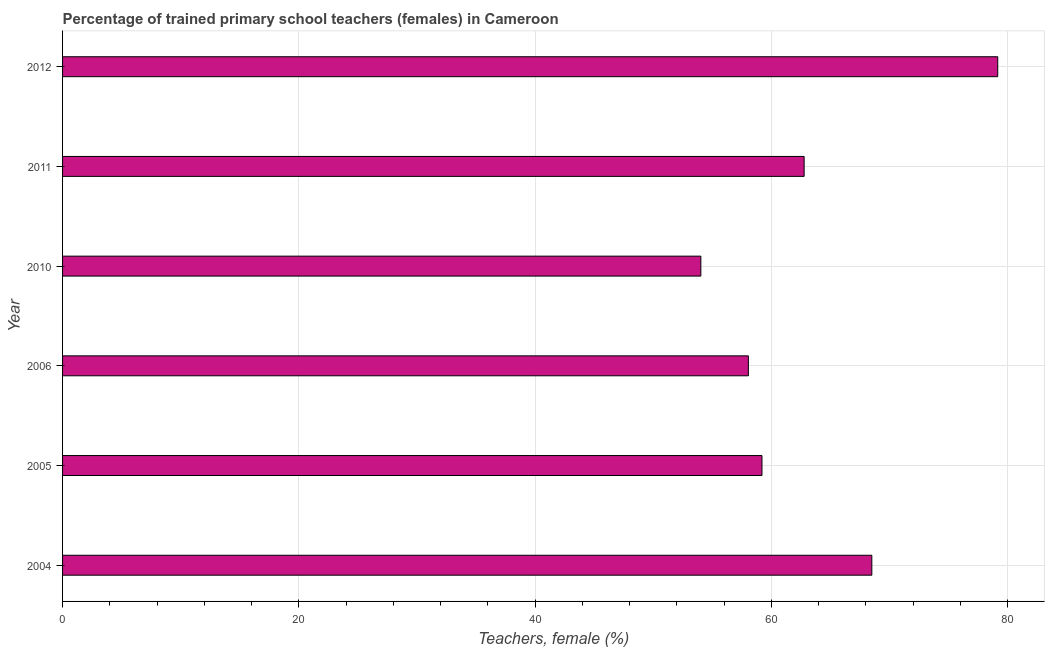Does the graph contain any zero values?
Provide a succinct answer. No. What is the title of the graph?
Make the answer very short. Percentage of trained primary school teachers (females) in Cameroon. What is the label or title of the X-axis?
Your response must be concise. Teachers, female (%). What is the label or title of the Y-axis?
Offer a very short reply. Year. What is the percentage of trained female teachers in 2004?
Ensure brevity in your answer.  68.5. Across all years, what is the maximum percentage of trained female teachers?
Keep it short and to the point. 79.15. Across all years, what is the minimum percentage of trained female teachers?
Keep it short and to the point. 54.02. In which year was the percentage of trained female teachers maximum?
Provide a short and direct response. 2012. In which year was the percentage of trained female teachers minimum?
Your answer should be very brief. 2010. What is the sum of the percentage of trained female teachers?
Provide a short and direct response. 381.68. What is the difference between the percentage of trained female teachers in 2006 and 2010?
Your answer should be compact. 4.02. What is the average percentage of trained female teachers per year?
Keep it short and to the point. 63.61. What is the median percentage of trained female teachers?
Your response must be concise. 60.98. Do a majority of the years between 2006 and 2012 (inclusive) have percentage of trained female teachers greater than 36 %?
Offer a terse response. Yes. What is the ratio of the percentage of trained female teachers in 2006 to that in 2012?
Make the answer very short. 0.73. Is the percentage of trained female teachers in 2005 less than that in 2012?
Give a very brief answer. Yes. Is the difference between the percentage of trained female teachers in 2004 and 2010 greater than the difference between any two years?
Your answer should be very brief. No. What is the difference between the highest and the second highest percentage of trained female teachers?
Your answer should be compact. 10.66. Is the sum of the percentage of trained female teachers in 2010 and 2011 greater than the maximum percentage of trained female teachers across all years?
Offer a very short reply. Yes. What is the difference between the highest and the lowest percentage of trained female teachers?
Keep it short and to the point. 25.13. Are the values on the major ticks of X-axis written in scientific E-notation?
Offer a very short reply. No. What is the Teachers, female (%) of 2004?
Offer a very short reply. 68.5. What is the Teachers, female (%) of 2005?
Give a very brief answer. 59.2. What is the Teachers, female (%) of 2006?
Offer a very short reply. 58.05. What is the Teachers, female (%) of 2010?
Provide a succinct answer. 54.02. What is the Teachers, female (%) in 2011?
Keep it short and to the point. 62.77. What is the Teachers, female (%) of 2012?
Provide a short and direct response. 79.15. What is the difference between the Teachers, female (%) in 2004 and 2005?
Provide a short and direct response. 9.3. What is the difference between the Teachers, female (%) in 2004 and 2006?
Provide a succinct answer. 10.45. What is the difference between the Teachers, female (%) in 2004 and 2010?
Provide a succinct answer. 14.47. What is the difference between the Teachers, female (%) in 2004 and 2011?
Make the answer very short. 5.73. What is the difference between the Teachers, female (%) in 2004 and 2012?
Your answer should be very brief. -10.66. What is the difference between the Teachers, female (%) in 2005 and 2006?
Give a very brief answer. 1.15. What is the difference between the Teachers, female (%) in 2005 and 2010?
Keep it short and to the point. 5.17. What is the difference between the Teachers, female (%) in 2005 and 2011?
Your answer should be very brief. -3.57. What is the difference between the Teachers, female (%) in 2005 and 2012?
Offer a very short reply. -19.95. What is the difference between the Teachers, female (%) in 2006 and 2010?
Provide a short and direct response. 4.02. What is the difference between the Teachers, female (%) in 2006 and 2011?
Ensure brevity in your answer.  -4.72. What is the difference between the Teachers, female (%) in 2006 and 2012?
Your answer should be compact. -21.11. What is the difference between the Teachers, female (%) in 2010 and 2011?
Your response must be concise. -8.74. What is the difference between the Teachers, female (%) in 2010 and 2012?
Your answer should be very brief. -25.13. What is the difference between the Teachers, female (%) in 2011 and 2012?
Provide a succinct answer. -16.39. What is the ratio of the Teachers, female (%) in 2004 to that in 2005?
Offer a very short reply. 1.16. What is the ratio of the Teachers, female (%) in 2004 to that in 2006?
Your response must be concise. 1.18. What is the ratio of the Teachers, female (%) in 2004 to that in 2010?
Provide a succinct answer. 1.27. What is the ratio of the Teachers, female (%) in 2004 to that in 2011?
Offer a terse response. 1.09. What is the ratio of the Teachers, female (%) in 2004 to that in 2012?
Your answer should be compact. 0.86. What is the ratio of the Teachers, female (%) in 2005 to that in 2010?
Provide a short and direct response. 1.1. What is the ratio of the Teachers, female (%) in 2005 to that in 2011?
Provide a succinct answer. 0.94. What is the ratio of the Teachers, female (%) in 2005 to that in 2012?
Offer a terse response. 0.75. What is the ratio of the Teachers, female (%) in 2006 to that in 2010?
Provide a succinct answer. 1.07. What is the ratio of the Teachers, female (%) in 2006 to that in 2011?
Your answer should be compact. 0.93. What is the ratio of the Teachers, female (%) in 2006 to that in 2012?
Provide a succinct answer. 0.73. What is the ratio of the Teachers, female (%) in 2010 to that in 2011?
Offer a terse response. 0.86. What is the ratio of the Teachers, female (%) in 2010 to that in 2012?
Offer a terse response. 0.68. What is the ratio of the Teachers, female (%) in 2011 to that in 2012?
Keep it short and to the point. 0.79. 